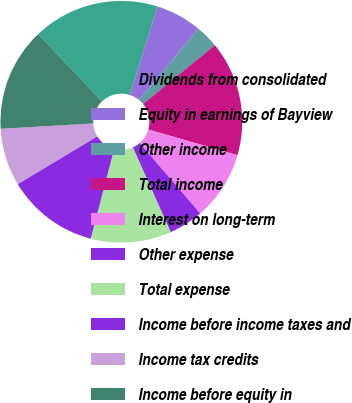Convert chart. <chart><loc_0><loc_0><loc_500><loc_500><pie_chart><fcel>Dividends from consolidated<fcel>Equity in earnings of Bayview<fcel>Other income<fcel>Total income<fcel>Interest on long-term<fcel>Other expense<fcel>Total expense<fcel>Income before income taxes and<fcel>Income tax credits<fcel>Income before equity in<nl><fcel>16.92%<fcel>6.15%<fcel>3.08%<fcel>15.38%<fcel>9.23%<fcel>4.62%<fcel>10.77%<fcel>12.31%<fcel>7.69%<fcel>13.85%<nl></chart> 